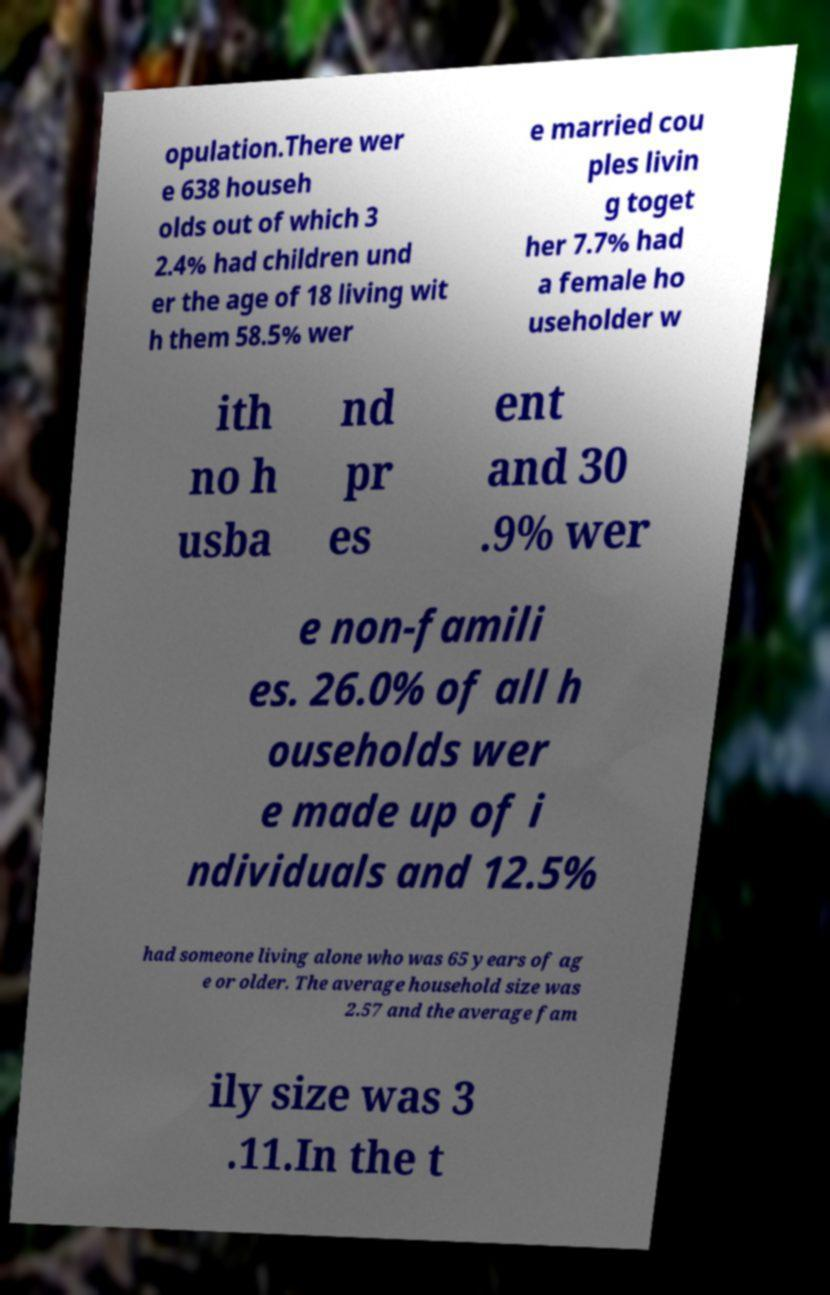Please read and relay the text visible in this image. What does it say? opulation.There wer e 638 househ olds out of which 3 2.4% had children und er the age of 18 living wit h them 58.5% wer e married cou ples livin g toget her 7.7% had a female ho useholder w ith no h usba nd pr es ent and 30 .9% wer e non-famili es. 26.0% of all h ouseholds wer e made up of i ndividuals and 12.5% had someone living alone who was 65 years of ag e or older. The average household size was 2.57 and the average fam ily size was 3 .11.In the t 